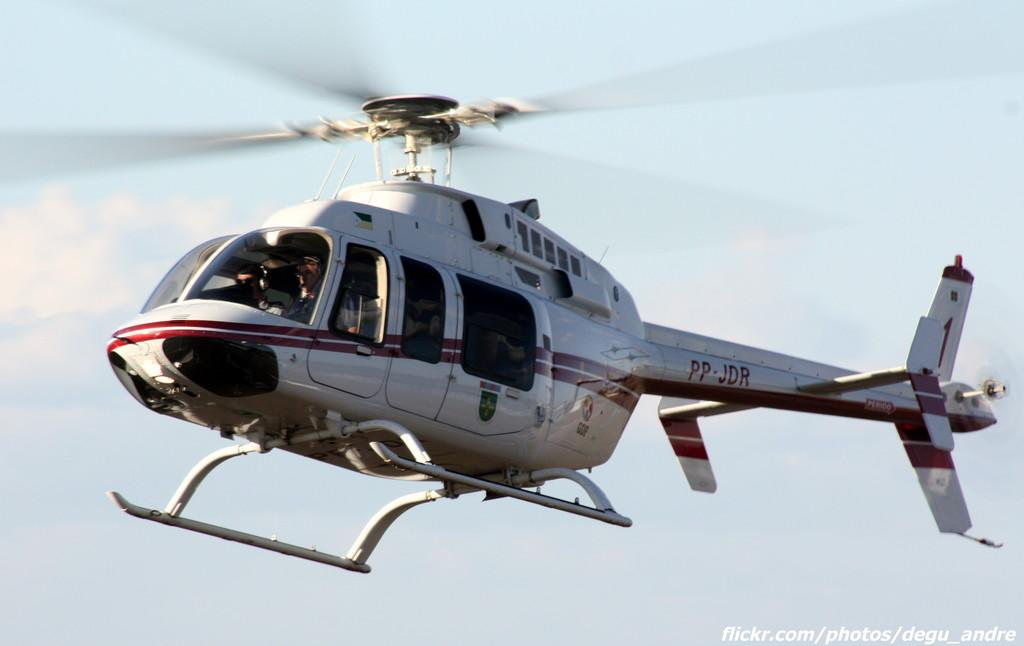Provide a one-sentence caption for the provided image. Helicopter number PP - JDR is in the sky. 